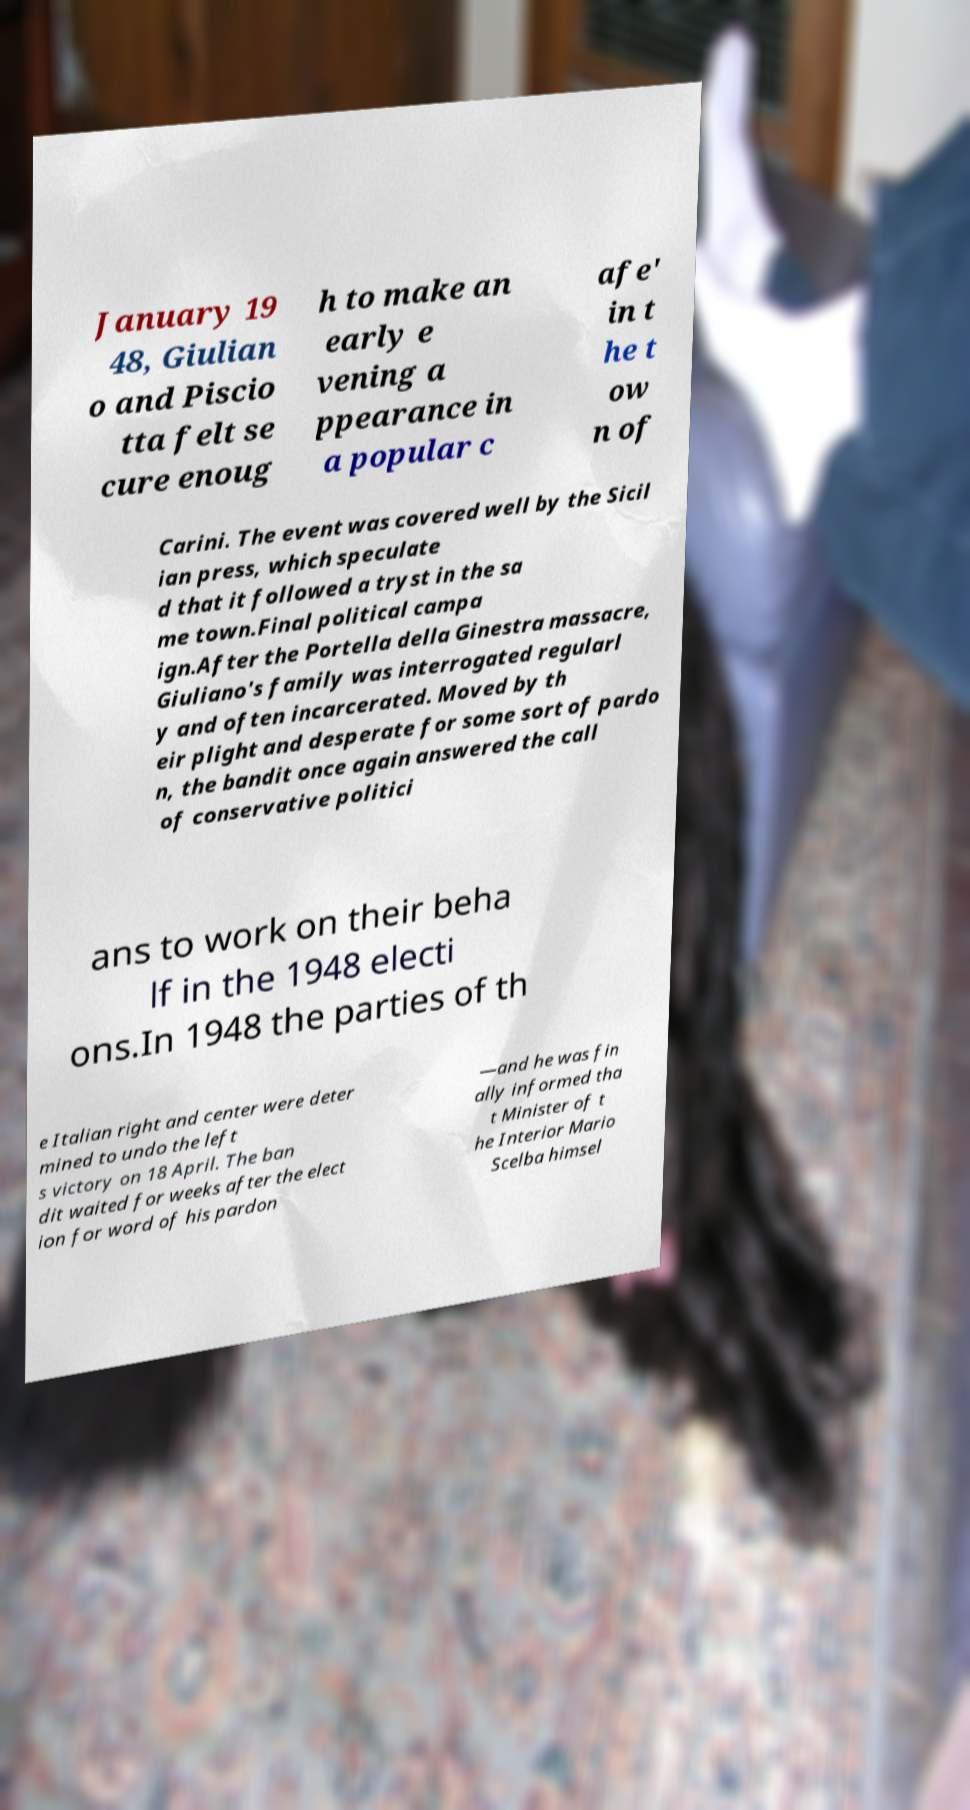Can you read and provide the text displayed in the image?This photo seems to have some interesting text. Can you extract and type it out for me? January 19 48, Giulian o and Piscio tta felt se cure enoug h to make an early e vening a ppearance in a popular c afe' in t he t ow n of Carini. The event was covered well by the Sicil ian press, which speculate d that it followed a tryst in the sa me town.Final political campa ign.After the Portella della Ginestra massacre, Giuliano's family was interrogated regularl y and often incarcerated. Moved by th eir plight and desperate for some sort of pardo n, the bandit once again answered the call of conservative politici ans to work on their beha lf in the 1948 electi ons.In 1948 the parties of th e Italian right and center were deter mined to undo the left s victory on 18 April. The ban dit waited for weeks after the elect ion for word of his pardon —and he was fin ally informed tha t Minister of t he Interior Mario Scelba himsel 